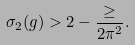<formula> <loc_0><loc_0><loc_500><loc_500>\sigma _ { 2 } ( g ) > 2 - \frac { \geq } { 2 \pi ^ { 2 } } .</formula> 